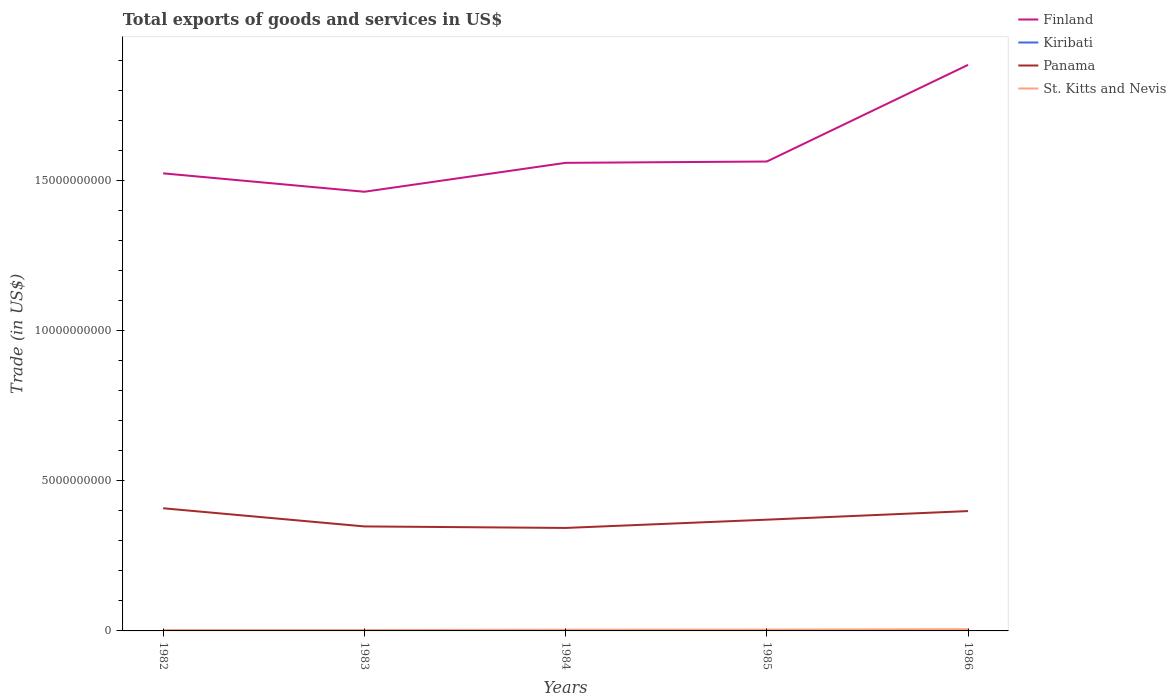Does the line corresponding to Finland intersect with the line corresponding to Kiribati?
Ensure brevity in your answer.  No. Across all years, what is the maximum total exports of goods and services in St. Kitts and Nevis?
Provide a short and direct response. 2.92e+07. In which year was the total exports of goods and services in St. Kitts and Nevis maximum?
Give a very brief answer. 1983. What is the total total exports of goods and services in Finland in the graph?
Ensure brevity in your answer.  -1.01e+09. What is the difference between the highest and the second highest total exports of goods and services in Kiribati?
Your response must be concise. 9.30e+06. How many years are there in the graph?
Provide a short and direct response. 5. What is the difference between two consecutive major ticks on the Y-axis?
Your answer should be compact. 5.00e+09. Does the graph contain grids?
Your answer should be compact. No. Where does the legend appear in the graph?
Your answer should be very brief. Top right. How many legend labels are there?
Provide a short and direct response. 4. What is the title of the graph?
Keep it short and to the point. Total exports of goods and services in US$. Does "Azerbaijan" appear as one of the legend labels in the graph?
Ensure brevity in your answer.  No. What is the label or title of the X-axis?
Your response must be concise. Years. What is the label or title of the Y-axis?
Provide a short and direct response. Trade (in US$). What is the Trade (in US$) in Finland in 1982?
Your answer should be very brief. 1.52e+1. What is the Trade (in US$) in Kiribati in 1982?
Provide a succinct answer. 2.69e+06. What is the Trade (in US$) of Panama in 1982?
Your answer should be very brief. 4.09e+09. What is the Trade (in US$) in St. Kitts and Nevis in 1982?
Keep it short and to the point. 2.99e+07. What is the Trade (in US$) in Finland in 1983?
Keep it short and to the point. 1.46e+1. What is the Trade (in US$) in Kiribati in 1983?
Provide a short and direct response. 3.90e+06. What is the Trade (in US$) in Panama in 1983?
Provide a short and direct response. 3.48e+09. What is the Trade (in US$) in St. Kitts and Nevis in 1983?
Offer a terse response. 2.92e+07. What is the Trade (in US$) of Finland in 1984?
Keep it short and to the point. 1.56e+1. What is the Trade (in US$) of Kiribati in 1984?
Give a very brief answer. 1.12e+07. What is the Trade (in US$) of Panama in 1984?
Offer a very short reply. 3.43e+09. What is the Trade (in US$) of St. Kitts and Nevis in 1984?
Your response must be concise. 3.85e+07. What is the Trade (in US$) of Finland in 1985?
Your answer should be compact. 1.56e+1. What is the Trade (in US$) of Kiribati in 1985?
Give a very brief answer. 4.49e+06. What is the Trade (in US$) of Panama in 1985?
Keep it short and to the point. 3.71e+09. What is the Trade (in US$) in St. Kitts and Nevis in 1985?
Provide a succinct answer. 4.32e+07. What is the Trade (in US$) in Finland in 1986?
Make the answer very short. 1.89e+1. What is the Trade (in US$) in Kiribati in 1986?
Your answer should be compact. 1.94e+06. What is the Trade (in US$) of Panama in 1986?
Your answer should be very brief. 3.99e+09. What is the Trade (in US$) of St. Kitts and Nevis in 1986?
Offer a terse response. 5.78e+07. Across all years, what is the maximum Trade (in US$) in Finland?
Give a very brief answer. 1.89e+1. Across all years, what is the maximum Trade (in US$) of Kiribati?
Ensure brevity in your answer.  1.12e+07. Across all years, what is the maximum Trade (in US$) in Panama?
Your response must be concise. 4.09e+09. Across all years, what is the maximum Trade (in US$) of St. Kitts and Nevis?
Provide a short and direct response. 5.78e+07. Across all years, what is the minimum Trade (in US$) of Finland?
Provide a succinct answer. 1.46e+1. Across all years, what is the minimum Trade (in US$) of Kiribati?
Keep it short and to the point. 1.94e+06. Across all years, what is the minimum Trade (in US$) in Panama?
Keep it short and to the point. 3.43e+09. Across all years, what is the minimum Trade (in US$) of St. Kitts and Nevis?
Provide a short and direct response. 2.92e+07. What is the total Trade (in US$) in Finland in the graph?
Provide a short and direct response. 8.00e+1. What is the total Trade (in US$) of Kiribati in the graph?
Provide a succinct answer. 2.43e+07. What is the total Trade (in US$) in Panama in the graph?
Give a very brief answer. 1.87e+1. What is the total Trade (in US$) of St. Kitts and Nevis in the graph?
Provide a succinct answer. 1.99e+08. What is the difference between the Trade (in US$) of Finland in 1982 and that in 1983?
Offer a terse response. 6.13e+08. What is the difference between the Trade (in US$) of Kiribati in 1982 and that in 1983?
Make the answer very short. -1.21e+06. What is the difference between the Trade (in US$) in Panama in 1982 and that in 1983?
Ensure brevity in your answer.  6.05e+08. What is the difference between the Trade (in US$) in St. Kitts and Nevis in 1982 and that in 1983?
Make the answer very short. 6.63e+05. What is the difference between the Trade (in US$) in Finland in 1982 and that in 1984?
Offer a very short reply. -3.50e+08. What is the difference between the Trade (in US$) in Kiribati in 1982 and that in 1984?
Provide a short and direct response. -8.55e+06. What is the difference between the Trade (in US$) in Panama in 1982 and that in 1984?
Give a very brief answer. 6.56e+08. What is the difference between the Trade (in US$) in St. Kitts and Nevis in 1982 and that in 1984?
Offer a terse response. -8.69e+06. What is the difference between the Trade (in US$) of Finland in 1982 and that in 1985?
Your response must be concise. -3.94e+08. What is the difference between the Trade (in US$) of Kiribati in 1982 and that in 1985?
Your answer should be very brief. -1.80e+06. What is the difference between the Trade (in US$) of Panama in 1982 and that in 1985?
Ensure brevity in your answer.  3.80e+08. What is the difference between the Trade (in US$) of St. Kitts and Nevis in 1982 and that in 1985?
Give a very brief answer. -1.33e+07. What is the difference between the Trade (in US$) in Finland in 1982 and that in 1986?
Provide a short and direct response. -3.61e+09. What is the difference between the Trade (in US$) of Kiribati in 1982 and that in 1986?
Your response must be concise. 7.50e+05. What is the difference between the Trade (in US$) of Panama in 1982 and that in 1986?
Provide a short and direct response. 9.40e+07. What is the difference between the Trade (in US$) in St. Kitts and Nevis in 1982 and that in 1986?
Your answer should be very brief. -2.80e+07. What is the difference between the Trade (in US$) in Finland in 1983 and that in 1984?
Offer a very short reply. -9.63e+08. What is the difference between the Trade (in US$) of Kiribati in 1983 and that in 1984?
Ensure brevity in your answer.  -7.34e+06. What is the difference between the Trade (in US$) in Panama in 1983 and that in 1984?
Offer a very short reply. 5.02e+07. What is the difference between the Trade (in US$) in St. Kitts and Nevis in 1983 and that in 1984?
Your answer should be very brief. -9.35e+06. What is the difference between the Trade (in US$) in Finland in 1983 and that in 1985?
Provide a succinct answer. -1.01e+09. What is the difference between the Trade (in US$) in Kiribati in 1983 and that in 1985?
Your answer should be compact. -5.96e+05. What is the difference between the Trade (in US$) of Panama in 1983 and that in 1985?
Make the answer very short. -2.25e+08. What is the difference between the Trade (in US$) in St. Kitts and Nevis in 1983 and that in 1985?
Give a very brief answer. -1.40e+07. What is the difference between the Trade (in US$) in Finland in 1983 and that in 1986?
Provide a succinct answer. -4.23e+09. What is the difference between the Trade (in US$) of Kiribati in 1983 and that in 1986?
Your answer should be very brief. 1.96e+06. What is the difference between the Trade (in US$) in Panama in 1983 and that in 1986?
Your answer should be very brief. -5.11e+08. What is the difference between the Trade (in US$) of St. Kitts and Nevis in 1983 and that in 1986?
Your answer should be compact. -2.86e+07. What is the difference between the Trade (in US$) of Finland in 1984 and that in 1985?
Ensure brevity in your answer.  -4.43e+07. What is the difference between the Trade (in US$) in Kiribati in 1984 and that in 1985?
Your response must be concise. 6.74e+06. What is the difference between the Trade (in US$) in Panama in 1984 and that in 1985?
Keep it short and to the point. -2.75e+08. What is the difference between the Trade (in US$) of St. Kitts and Nevis in 1984 and that in 1985?
Provide a short and direct response. -4.64e+06. What is the difference between the Trade (in US$) in Finland in 1984 and that in 1986?
Keep it short and to the point. -3.26e+09. What is the difference between the Trade (in US$) in Kiribati in 1984 and that in 1986?
Your response must be concise. 9.30e+06. What is the difference between the Trade (in US$) in Panama in 1984 and that in 1986?
Ensure brevity in your answer.  -5.62e+08. What is the difference between the Trade (in US$) in St. Kitts and Nevis in 1984 and that in 1986?
Offer a very short reply. -1.93e+07. What is the difference between the Trade (in US$) in Finland in 1985 and that in 1986?
Your response must be concise. -3.22e+09. What is the difference between the Trade (in US$) of Kiribati in 1985 and that in 1986?
Offer a terse response. 2.55e+06. What is the difference between the Trade (in US$) of Panama in 1985 and that in 1986?
Offer a very short reply. -2.86e+08. What is the difference between the Trade (in US$) of St. Kitts and Nevis in 1985 and that in 1986?
Give a very brief answer. -1.47e+07. What is the difference between the Trade (in US$) of Finland in 1982 and the Trade (in US$) of Kiribati in 1983?
Your answer should be very brief. 1.52e+1. What is the difference between the Trade (in US$) in Finland in 1982 and the Trade (in US$) in Panama in 1983?
Offer a very short reply. 1.18e+1. What is the difference between the Trade (in US$) in Finland in 1982 and the Trade (in US$) in St. Kitts and Nevis in 1983?
Offer a terse response. 1.52e+1. What is the difference between the Trade (in US$) in Kiribati in 1982 and the Trade (in US$) in Panama in 1983?
Keep it short and to the point. -3.48e+09. What is the difference between the Trade (in US$) in Kiribati in 1982 and the Trade (in US$) in St. Kitts and Nevis in 1983?
Provide a short and direct response. -2.65e+07. What is the difference between the Trade (in US$) in Panama in 1982 and the Trade (in US$) in St. Kitts and Nevis in 1983?
Provide a short and direct response. 4.06e+09. What is the difference between the Trade (in US$) of Finland in 1982 and the Trade (in US$) of Kiribati in 1984?
Your answer should be very brief. 1.52e+1. What is the difference between the Trade (in US$) of Finland in 1982 and the Trade (in US$) of Panama in 1984?
Offer a very short reply. 1.18e+1. What is the difference between the Trade (in US$) of Finland in 1982 and the Trade (in US$) of St. Kitts and Nevis in 1984?
Provide a short and direct response. 1.52e+1. What is the difference between the Trade (in US$) in Kiribati in 1982 and the Trade (in US$) in Panama in 1984?
Make the answer very short. -3.43e+09. What is the difference between the Trade (in US$) of Kiribati in 1982 and the Trade (in US$) of St. Kitts and Nevis in 1984?
Provide a succinct answer. -3.59e+07. What is the difference between the Trade (in US$) in Panama in 1982 and the Trade (in US$) in St. Kitts and Nevis in 1984?
Offer a terse response. 4.05e+09. What is the difference between the Trade (in US$) of Finland in 1982 and the Trade (in US$) of Kiribati in 1985?
Make the answer very short. 1.52e+1. What is the difference between the Trade (in US$) in Finland in 1982 and the Trade (in US$) in Panama in 1985?
Provide a succinct answer. 1.15e+1. What is the difference between the Trade (in US$) in Finland in 1982 and the Trade (in US$) in St. Kitts and Nevis in 1985?
Your answer should be very brief. 1.52e+1. What is the difference between the Trade (in US$) in Kiribati in 1982 and the Trade (in US$) in Panama in 1985?
Your answer should be very brief. -3.70e+09. What is the difference between the Trade (in US$) in Kiribati in 1982 and the Trade (in US$) in St. Kitts and Nevis in 1985?
Provide a short and direct response. -4.05e+07. What is the difference between the Trade (in US$) of Panama in 1982 and the Trade (in US$) of St. Kitts and Nevis in 1985?
Your answer should be compact. 4.04e+09. What is the difference between the Trade (in US$) in Finland in 1982 and the Trade (in US$) in Kiribati in 1986?
Provide a short and direct response. 1.52e+1. What is the difference between the Trade (in US$) in Finland in 1982 and the Trade (in US$) in Panama in 1986?
Your answer should be very brief. 1.13e+1. What is the difference between the Trade (in US$) of Finland in 1982 and the Trade (in US$) of St. Kitts and Nevis in 1986?
Offer a terse response. 1.52e+1. What is the difference between the Trade (in US$) in Kiribati in 1982 and the Trade (in US$) in Panama in 1986?
Your answer should be compact. -3.99e+09. What is the difference between the Trade (in US$) of Kiribati in 1982 and the Trade (in US$) of St. Kitts and Nevis in 1986?
Your answer should be compact. -5.52e+07. What is the difference between the Trade (in US$) in Panama in 1982 and the Trade (in US$) in St. Kitts and Nevis in 1986?
Provide a short and direct response. 4.03e+09. What is the difference between the Trade (in US$) in Finland in 1983 and the Trade (in US$) in Kiribati in 1984?
Ensure brevity in your answer.  1.46e+1. What is the difference between the Trade (in US$) in Finland in 1983 and the Trade (in US$) in Panama in 1984?
Your answer should be very brief. 1.12e+1. What is the difference between the Trade (in US$) of Finland in 1983 and the Trade (in US$) of St. Kitts and Nevis in 1984?
Your response must be concise. 1.46e+1. What is the difference between the Trade (in US$) of Kiribati in 1983 and the Trade (in US$) of Panama in 1984?
Provide a succinct answer. -3.43e+09. What is the difference between the Trade (in US$) of Kiribati in 1983 and the Trade (in US$) of St. Kitts and Nevis in 1984?
Offer a very short reply. -3.46e+07. What is the difference between the Trade (in US$) of Panama in 1983 and the Trade (in US$) of St. Kitts and Nevis in 1984?
Give a very brief answer. 3.44e+09. What is the difference between the Trade (in US$) in Finland in 1983 and the Trade (in US$) in Kiribati in 1985?
Provide a succinct answer. 1.46e+1. What is the difference between the Trade (in US$) of Finland in 1983 and the Trade (in US$) of Panama in 1985?
Your answer should be very brief. 1.09e+1. What is the difference between the Trade (in US$) of Finland in 1983 and the Trade (in US$) of St. Kitts and Nevis in 1985?
Keep it short and to the point. 1.46e+1. What is the difference between the Trade (in US$) of Kiribati in 1983 and the Trade (in US$) of Panama in 1985?
Give a very brief answer. -3.70e+09. What is the difference between the Trade (in US$) of Kiribati in 1983 and the Trade (in US$) of St. Kitts and Nevis in 1985?
Your answer should be very brief. -3.93e+07. What is the difference between the Trade (in US$) in Panama in 1983 and the Trade (in US$) in St. Kitts and Nevis in 1985?
Offer a very short reply. 3.44e+09. What is the difference between the Trade (in US$) in Finland in 1983 and the Trade (in US$) in Kiribati in 1986?
Provide a succinct answer. 1.46e+1. What is the difference between the Trade (in US$) of Finland in 1983 and the Trade (in US$) of Panama in 1986?
Make the answer very short. 1.06e+1. What is the difference between the Trade (in US$) of Finland in 1983 and the Trade (in US$) of St. Kitts and Nevis in 1986?
Ensure brevity in your answer.  1.46e+1. What is the difference between the Trade (in US$) of Kiribati in 1983 and the Trade (in US$) of Panama in 1986?
Offer a terse response. -3.99e+09. What is the difference between the Trade (in US$) of Kiribati in 1983 and the Trade (in US$) of St. Kitts and Nevis in 1986?
Offer a very short reply. -5.39e+07. What is the difference between the Trade (in US$) in Panama in 1983 and the Trade (in US$) in St. Kitts and Nevis in 1986?
Ensure brevity in your answer.  3.42e+09. What is the difference between the Trade (in US$) of Finland in 1984 and the Trade (in US$) of Kiribati in 1985?
Your response must be concise. 1.56e+1. What is the difference between the Trade (in US$) of Finland in 1984 and the Trade (in US$) of Panama in 1985?
Provide a short and direct response. 1.19e+1. What is the difference between the Trade (in US$) in Finland in 1984 and the Trade (in US$) in St. Kitts and Nevis in 1985?
Keep it short and to the point. 1.56e+1. What is the difference between the Trade (in US$) in Kiribati in 1984 and the Trade (in US$) in Panama in 1985?
Make the answer very short. -3.70e+09. What is the difference between the Trade (in US$) in Kiribati in 1984 and the Trade (in US$) in St. Kitts and Nevis in 1985?
Make the answer very short. -3.20e+07. What is the difference between the Trade (in US$) of Panama in 1984 and the Trade (in US$) of St. Kitts and Nevis in 1985?
Keep it short and to the point. 3.39e+09. What is the difference between the Trade (in US$) of Finland in 1984 and the Trade (in US$) of Kiribati in 1986?
Your answer should be very brief. 1.56e+1. What is the difference between the Trade (in US$) in Finland in 1984 and the Trade (in US$) in Panama in 1986?
Offer a terse response. 1.16e+1. What is the difference between the Trade (in US$) in Finland in 1984 and the Trade (in US$) in St. Kitts and Nevis in 1986?
Your response must be concise. 1.55e+1. What is the difference between the Trade (in US$) in Kiribati in 1984 and the Trade (in US$) in Panama in 1986?
Your answer should be very brief. -3.98e+09. What is the difference between the Trade (in US$) in Kiribati in 1984 and the Trade (in US$) in St. Kitts and Nevis in 1986?
Provide a short and direct response. -4.66e+07. What is the difference between the Trade (in US$) in Panama in 1984 and the Trade (in US$) in St. Kitts and Nevis in 1986?
Keep it short and to the point. 3.37e+09. What is the difference between the Trade (in US$) of Finland in 1985 and the Trade (in US$) of Kiribati in 1986?
Make the answer very short. 1.56e+1. What is the difference between the Trade (in US$) of Finland in 1985 and the Trade (in US$) of Panama in 1986?
Provide a succinct answer. 1.16e+1. What is the difference between the Trade (in US$) in Finland in 1985 and the Trade (in US$) in St. Kitts and Nevis in 1986?
Keep it short and to the point. 1.56e+1. What is the difference between the Trade (in US$) of Kiribati in 1985 and the Trade (in US$) of Panama in 1986?
Ensure brevity in your answer.  -3.99e+09. What is the difference between the Trade (in US$) in Kiribati in 1985 and the Trade (in US$) in St. Kitts and Nevis in 1986?
Give a very brief answer. -5.34e+07. What is the difference between the Trade (in US$) of Panama in 1985 and the Trade (in US$) of St. Kitts and Nevis in 1986?
Provide a short and direct response. 3.65e+09. What is the average Trade (in US$) in Finland per year?
Ensure brevity in your answer.  1.60e+1. What is the average Trade (in US$) of Kiribati per year?
Your answer should be very brief. 4.85e+06. What is the average Trade (in US$) in Panama per year?
Give a very brief answer. 3.74e+09. What is the average Trade (in US$) of St. Kitts and Nevis per year?
Offer a terse response. 3.97e+07. In the year 1982, what is the difference between the Trade (in US$) of Finland and Trade (in US$) of Kiribati?
Keep it short and to the point. 1.52e+1. In the year 1982, what is the difference between the Trade (in US$) of Finland and Trade (in US$) of Panama?
Offer a very short reply. 1.12e+1. In the year 1982, what is the difference between the Trade (in US$) of Finland and Trade (in US$) of St. Kitts and Nevis?
Make the answer very short. 1.52e+1. In the year 1982, what is the difference between the Trade (in US$) of Kiribati and Trade (in US$) of Panama?
Provide a short and direct response. -4.08e+09. In the year 1982, what is the difference between the Trade (in US$) of Kiribati and Trade (in US$) of St. Kitts and Nevis?
Make the answer very short. -2.72e+07. In the year 1982, what is the difference between the Trade (in US$) in Panama and Trade (in US$) in St. Kitts and Nevis?
Make the answer very short. 4.06e+09. In the year 1983, what is the difference between the Trade (in US$) of Finland and Trade (in US$) of Kiribati?
Make the answer very short. 1.46e+1. In the year 1983, what is the difference between the Trade (in US$) in Finland and Trade (in US$) in Panama?
Your response must be concise. 1.12e+1. In the year 1983, what is the difference between the Trade (in US$) in Finland and Trade (in US$) in St. Kitts and Nevis?
Offer a terse response. 1.46e+1. In the year 1983, what is the difference between the Trade (in US$) in Kiribati and Trade (in US$) in Panama?
Ensure brevity in your answer.  -3.48e+09. In the year 1983, what is the difference between the Trade (in US$) in Kiribati and Trade (in US$) in St. Kitts and Nevis?
Keep it short and to the point. -2.53e+07. In the year 1983, what is the difference between the Trade (in US$) in Panama and Trade (in US$) in St. Kitts and Nevis?
Offer a terse response. 3.45e+09. In the year 1984, what is the difference between the Trade (in US$) in Finland and Trade (in US$) in Kiribati?
Provide a succinct answer. 1.56e+1. In the year 1984, what is the difference between the Trade (in US$) of Finland and Trade (in US$) of Panama?
Your response must be concise. 1.22e+1. In the year 1984, what is the difference between the Trade (in US$) of Finland and Trade (in US$) of St. Kitts and Nevis?
Offer a very short reply. 1.56e+1. In the year 1984, what is the difference between the Trade (in US$) in Kiribati and Trade (in US$) in Panama?
Give a very brief answer. -3.42e+09. In the year 1984, what is the difference between the Trade (in US$) of Kiribati and Trade (in US$) of St. Kitts and Nevis?
Give a very brief answer. -2.73e+07. In the year 1984, what is the difference between the Trade (in US$) in Panama and Trade (in US$) in St. Kitts and Nevis?
Offer a very short reply. 3.39e+09. In the year 1985, what is the difference between the Trade (in US$) in Finland and Trade (in US$) in Kiribati?
Offer a terse response. 1.56e+1. In the year 1985, what is the difference between the Trade (in US$) in Finland and Trade (in US$) in Panama?
Keep it short and to the point. 1.19e+1. In the year 1985, what is the difference between the Trade (in US$) in Finland and Trade (in US$) in St. Kitts and Nevis?
Offer a very short reply. 1.56e+1. In the year 1985, what is the difference between the Trade (in US$) in Kiribati and Trade (in US$) in Panama?
Give a very brief answer. -3.70e+09. In the year 1985, what is the difference between the Trade (in US$) in Kiribati and Trade (in US$) in St. Kitts and Nevis?
Make the answer very short. -3.87e+07. In the year 1985, what is the difference between the Trade (in US$) in Panama and Trade (in US$) in St. Kitts and Nevis?
Provide a short and direct response. 3.66e+09. In the year 1986, what is the difference between the Trade (in US$) in Finland and Trade (in US$) in Kiribati?
Give a very brief answer. 1.89e+1. In the year 1986, what is the difference between the Trade (in US$) of Finland and Trade (in US$) of Panama?
Keep it short and to the point. 1.49e+1. In the year 1986, what is the difference between the Trade (in US$) in Finland and Trade (in US$) in St. Kitts and Nevis?
Your answer should be compact. 1.88e+1. In the year 1986, what is the difference between the Trade (in US$) in Kiribati and Trade (in US$) in Panama?
Offer a terse response. -3.99e+09. In the year 1986, what is the difference between the Trade (in US$) of Kiribati and Trade (in US$) of St. Kitts and Nevis?
Give a very brief answer. -5.59e+07. In the year 1986, what is the difference between the Trade (in US$) in Panama and Trade (in US$) in St. Kitts and Nevis?
Ensure brevity in your answer.  3.93e+09. What is the ratio of the Trade (in US$) of Finland in 1982 to that in 1983?
Provide a succinct answer. 1.04. What is the ratio of the Trade (in US$) in Kiribati in 1982 to that in 1983?
Your response must be concise. 0.69. What is the ratio of the Trade (in US$) in Panama in 1982 to that in 1983?
Your answer should be very brief. 1.17. What is the ratio of the Trade (in US$) in St. Kitts and Nevis in 1982 to that in 1983?
Offer a very short reply. 1.02. What is the ratio of the Trade (in US$) in Finland in 1982 to that in 1984?
Offer a terse response. 0.98. What is the ratio of the Trade (in US$) of Kiribati in 1982 to that in 1984?
Your answer should be compact. 0.24. What is the ratio of the Trade (in US$) in Panama in 1982 to that in 1984?
Make the answer very short. 1.19. What is the ratio of the Trade (in US$) of St. Kitts and Nevis in 1982 to that in 1984?
Offer a terse response. 0.77. What is the ratio of the Trade (in US$) of Finland in 1982 to that in 1985?
Your response must be concise. 0.97. What is the ratio of the Trade (in US$) of Kiribati in 1982 to that in 1985?
Provide a succinct answer. 0.6. What is the ratio of the Trade (in US$) of Panama in 1982 to that in 1985?
Ensure brevity in your answer.  1.1. What is the ratio of the Trade (in US$) in St. Kitts and Nevis in 1982 to that in 1985?
Make the answer very short. 0.69. What is the ratio of the Trade (in US$) in Finland in 1982 to that in 1986?
Make the answer very short. 0.81. What is the ratio of the Trade (in US$) of Kiribati in 1982 to that in 1986?
Your answer should be compact. 1.39. What is the ratio of the Trade (in US$) of Panama in 1982 to that in 1986?
Give a very brief answer. 1.02. What is the ratio of the Trade (in US$) of St. Kitts and Nevis in 1982 to that in 1986?
Offer a very short reply. 0.52. What is the ratio of the Trade (in US$) in Finland in 1983 to that in 1984?
Make the answer very short. 0.94. What is the ratio of the Trade (in US$) in Kiribati in 1983 to that in 1984?
Provide a succinct answer. 0.35. What is the ratio of the Trade (in US$) in Panama in 1983 to that in 1984?
Provide a succinct answer. 1.01. What is the ratio of the Trade (in US$) of St. Kitts and Nevis in 1983 to that in 1984?
Make the answer very short. 0.76. What is the ratio of the Trade (in US$) of Finland in 1983 to that in 1985?
Your answer should be compact. 0.94. What is the ratio of the Trade (in US$) of Kiribati in 1983 to that in 1985?
Provide a short and direct response. 0.87. What is the ratio of the Trade (in US$) of Panama in 1983 to that in 1985?
Provide a short and direct response. 0.94. What is the ratio of the Trade (in US$) in St. Kitts and Nevis in 1983 to that in 1985?
Offer a terse response. 0.68. What is the ratio of the Trade (in US$) of Finland in 1983 to that in 1986?
Offer a very short reply. 0.78. What is the ratio of the Trade (in US$) in Kiribati in 1983 to that in 1986?
Your response must be concise. 2.01. What is the ratio of the Trade (in US$) in Panama in 1983 to that in 1986?
Provide a short and direct response. 0.87. What is the ratio of the Trade (in US$) in St. Kitts and Nevis in 1983 to that in 1986?
Give a very brief answer. 0.5. What is the ratio of the Trade (in US$) of Kiribati in 1984 to that in 1985?
Give a very brief answer. 2.5. What is the ratio of the Trade (in US$) of Panama in 1984 to that in 1985?
Give a very brief answer. 0.93. What is the ratio of the Trade (in US$) of St. Kitts and Nevis in 1984 to that in 1985?
Make the answer very short. 0.89. What is the ratio of the Trade (in US$) in Finland in 1984 to that in 1986?
Offer a very short reply. 0.83. What is the ratio of the Trade (in US$) of Kiribati in 1984 to that in 1986?
Keep it short and to the point. 5.79. What is the ratio of the Trade (in US$) of Panama in 1984 to that in 1986?
Provide a succinct answer. 0.86. What is the ratio of the Trade (in US$) of St. Kitts and Nevis in 1984 to that in 1986?
Your response must be concise. 0.67. What is the ratio of the Trade (in US$) of Finland in 1985 to that in 1986?
Your answer should be very brief. 0.83. What is the ratio of the Trade (in US$) in Kiribati in 1985 to that in 1986?
Keep it short and to the point. 2.32. What is the ratio of the Trade (in US$) of Panama in 1985 to that in 1986?
Your answer should be very brief. 0.93. What is the ratio of the Trade (in US$) of St. Kitts and Nevis in 1985 to that in 1986?
Offer a terse response. 0.75. What is the difference between the highest and the second highest Trade (in US$) in Finland?
Your answer should be compact. 3.22e+09. What is the difference between the highest and the second highest Trade (in US$) in Kiribati?
Make the answer very short. 6.74e+06. What is the difference between the highest and the second highest Trade (in US$) in Panama?
Make the answer very short. 9.40e+07. What is the difference between the highest and the second highest Trade (in US$) in St. Kitts and Nevis?
Provide a succinct answer. 1.47e+07. What is the difference between the highest and the lowest Trade (in US$) in Finland?
Ensure brevity in your answer.  4.23e+09. What is the difference between the highest and the lowest Trade (in US$) of Kiribati?
Offer a very short reply. 9.30e+06. What is the difference between the highest and the lowest Trade (in US$) in Panama?
Keep it short and to the point. 6.56e+08. What is the difference between the highest and the lowest Trade (in US$) in St. Kitts and Nevis?
Provide a short and direct response. 2.86e+07. 